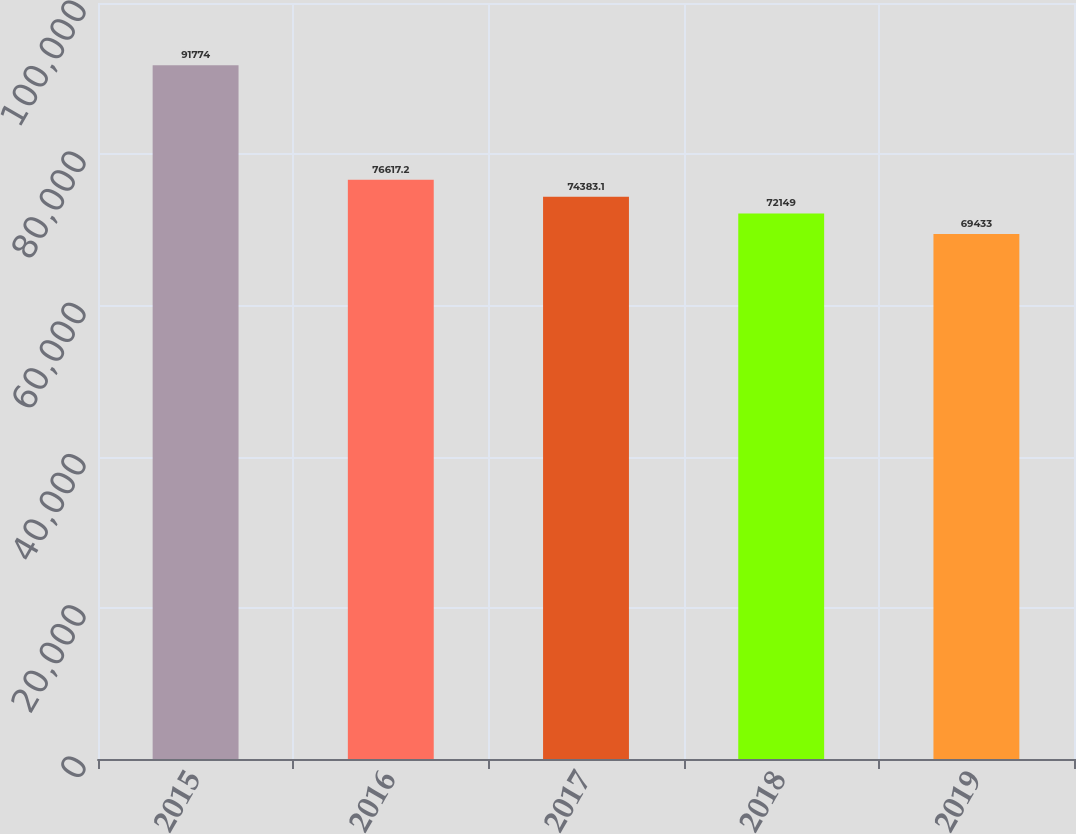<chart> <loc_0><loc_0><loc_500><loc_500><bar_chart><fcel>2015<fcel>2016<fcel>2017<fcel>2018<fcel>2019<nl><fcel>91774<fcel>76617.2<fcel>74383.1<fcel>72149<fcel>69433<nl></chart> 